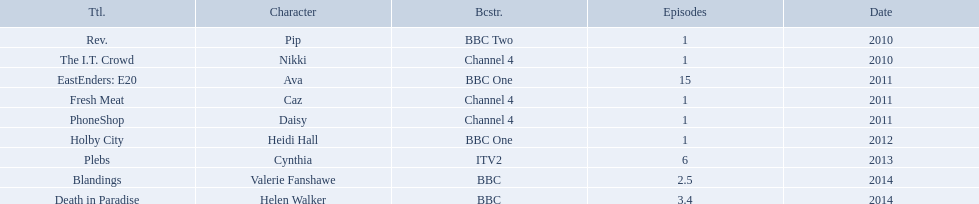How many episodes did sophie colquhoun star in on rev.? 1. What character did she play on phoneshop? Daisy. What role did she play on itv2? Cynthia. What roles did she play? Pip, Nikki, Ava, Caz, Daisy, Heidi Hall, Cynthia, Valerie Fanshawe, Helen Walker. On which broadcasters? BBC Two, Channel 4, BBC One, Channel 4, Channel 4, BBC One, ITV2, BBC, BBC. Which roles did she play for itv2? Cynthia. 